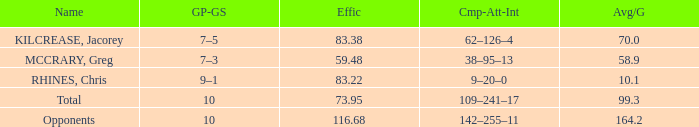What is the total avg/g of McCrary, Greg? 1.0. 